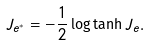Convert formula to latex. <formula><loc_0><loc_0><loc_500><loc_500>J _ { e ^ { * } } = - \frac { 1 } { 2 } \log \tanh J _ { e } .</formula> 